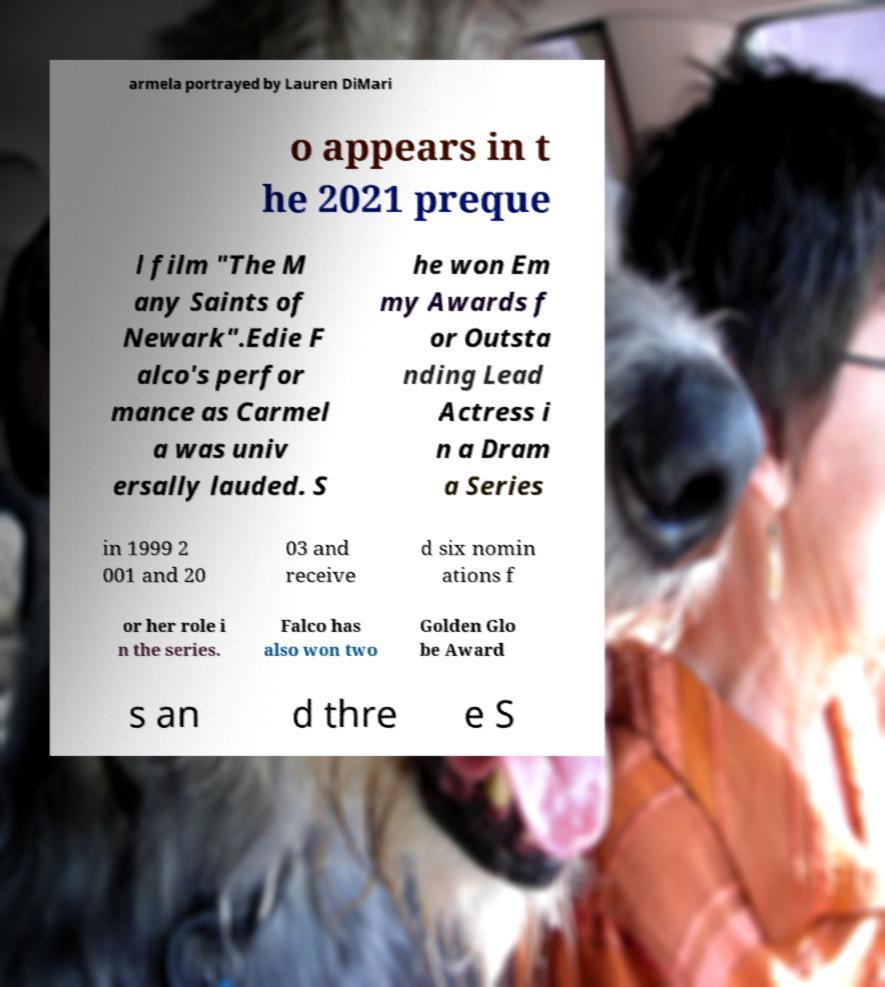I need the written content from this picture converted into text. Can you do that? armela portrayed by Lauren DiMari o appears in t he 2021 preque l film "The M any Saints of Newark".Edie F alco's perfor mance as Carmel a was univ ersally lauded. S he won Em my Awards f or Outsta nding Lead Actress i n a Dram a Series in 1999 2 001 and 20 03 and receive d six nomin ations f or her role i n the series. Falco has also won two Golden Glo be Award s an d thre e S 